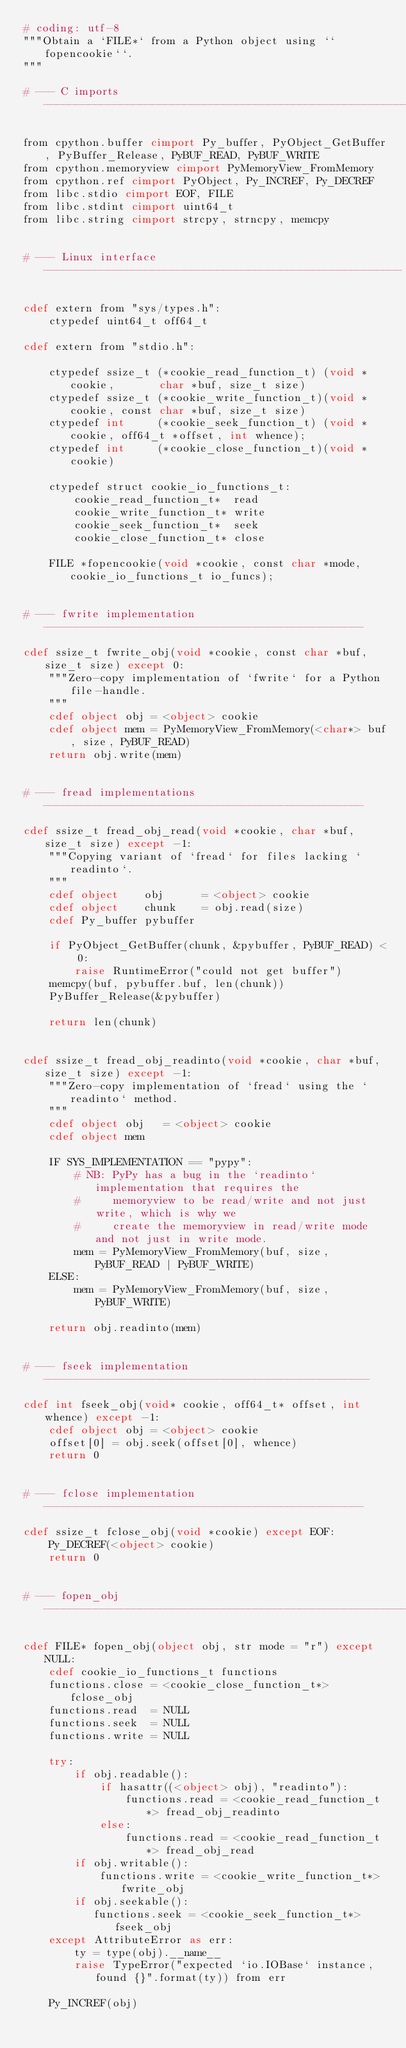Convert code to text. <code><loc_0><loc_0><loc_500><loc_500><_Cython_># coding: utf-8
"""Obtain a `FILE*` from a Python object using ``fopencookie``.
"""

# --- C imports --------------------------------------------------------------

from cpython.buffer cimport Py_buffer, PyObject_GetBuffer, PyBuffer_Release, PyBUF_READ, PyBUF_WRITE
from cpython.memoryview cimport PyMemoryView_FromMemory
from cpython.ref cimport PyObject, Py_INCREF, Py_DECREF
from libc.stdio cimport EOF, FILE
from libc.stdint cimport uint64_t
from libc.string cimport strcpy, strncpy, memcpy


# --- Linux interface --------------------------------------------------------

cdef extern from "sys/types.h":
    ctypedef uint64_t off64_t

cdef extern from "stdio.h":

    ctypedef ssize_t (*cookie_read_function_t) (void *cookie,       char *buf, size_t size)
    ctypedef ssize_t (*cookie_write_function_t)(void *cookie, const char *buf, size_t size)
    ctypedef int     (*cookie_seek_function_t) (void *cookie, off64_t *offset, int whence);
    ctypedef int     (*cookie_close_function_t)(void *cookie)

    ctypedef struct cookie_io_functions_t:
        cookie_read_function_t*  read
        cookie_write_function_t* write
        cookie_seek_function_t*  seek
        cookie_close_function_t* close

    FILE *fopencookie(void *cookie, const char *mode, cookie_io_functions_t io_funcs);


# --- fwrite implementation --------------------------------------------------

cdef ssize_t fwrite_obj(void *cookie, const char *buf, size_t size) except 0:
    """Zero-copy implementation of `fwrite` for a Python file-handle.
    """
    cdef object obj = <object> cookie
    cdef object mem = PyMemoryView_FromMemory(<char*> buf, size, PyBUF_READ)
    return obj.write(mem)


# --- fread implementations --------------------------------------------------

cdef ssize_t fread_obj_read(void *cookie, char *buf, size_t size) except -1:
    """Copying variant of `fread` for files lacking `readinto`.
    """
    cdef object    obj      = <object> cookie
    cdef object    chunk    = obj.read(size)
    cdef Py_buffer pybuffer

    if PyObject_GetBuffer(chunk, &pybuffer, PyBUF_READ) < 0:
        raise RuntimeError("could not get buffer")
    memcpy(buf, pybuffer.buf, len(chunk))
    PyBuffer_Release(&pybuffer)

    return len(chunk)


cdef ssize_t fread_obj_readinto(void *cookie, char *buf, size_t size) except -1:
    """Zero-copy implementation of `fread` using the `readinto` method.
    """
    cdef object obj   = <object> cookie
    cdef object mem

    IF SYS_IMPLEMENTATION == "pypy":
        # NB: PyPy has a bug in the `readinto` implementation that requires the
        #     memoryview to be read/write and not just write, which is why we
        #     create the memoryview in read/write mode and not just in write mode.
        mem = PyMemoryView_FromMemory(buf, size, PyBUF_READ | PyBUF_WRITE)
    ELSE:
        mem = PyMemoryView_FromMemory(buf, size, PyBUF_WRITE)
        
    return obj.readinto(mem)


# --- fseek implementation ---------------------------------------------------

cdef int fseek_obj(void* cookie, off64_t* offset, int whence) except -1:
    cdef object obj = <object> cookie
    offset[0] = obj.seek(offset[0], whence)
    return 0


# --- fclose implementation --------------------------------------------------

cdef ssize_t fclose_obj(void *cookie) except EOF:
    Py_DECREF(<object> cookie)
    return 0


# --- fopen_obj --------------------------------------------------------------

cdef FILE* fopen_obj(object obj, str mode = "r") except NULL:
    cdef cookie_io_functions_t functions
    functions.close = <cookie_close_function_t*> fclose_obj
    functions.read  = NULL
    functions.seek  = NULL
    functions.write = NULL

    try:
        if obj.readable():
            if hasattr((<object> obj), "readinto"):
                functions.read = <cookie_read_function_t*> fread_obj_readinto
            else:
                functions.read = <cookie_read_function_t*> fread_obj_read
        if obj.writable():
            functions.write = <cookie_write_function_t*> fwrite_obj
        if obj.seekable():
           functions.seek = <cookie_seek_function_t*> fseek_obj
    except AttributeError as err:
        ty = type(obj).__name__
        raise TypeError("expected `io.IOBase` instance, found {}".format(ty)) from err

    Py_INCREF(obj)</code> 